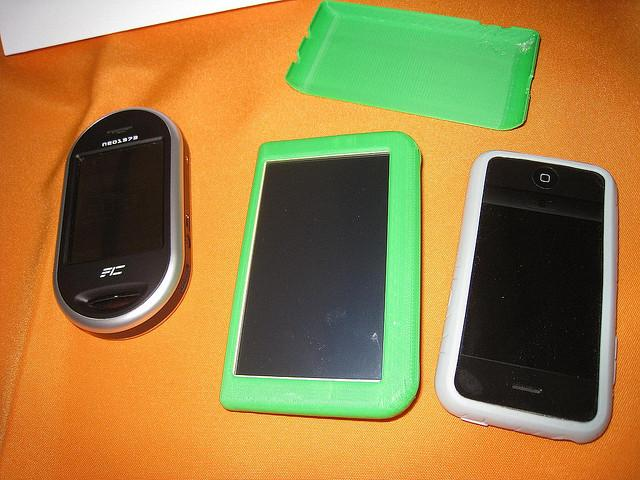What is all the way to the right? phone 